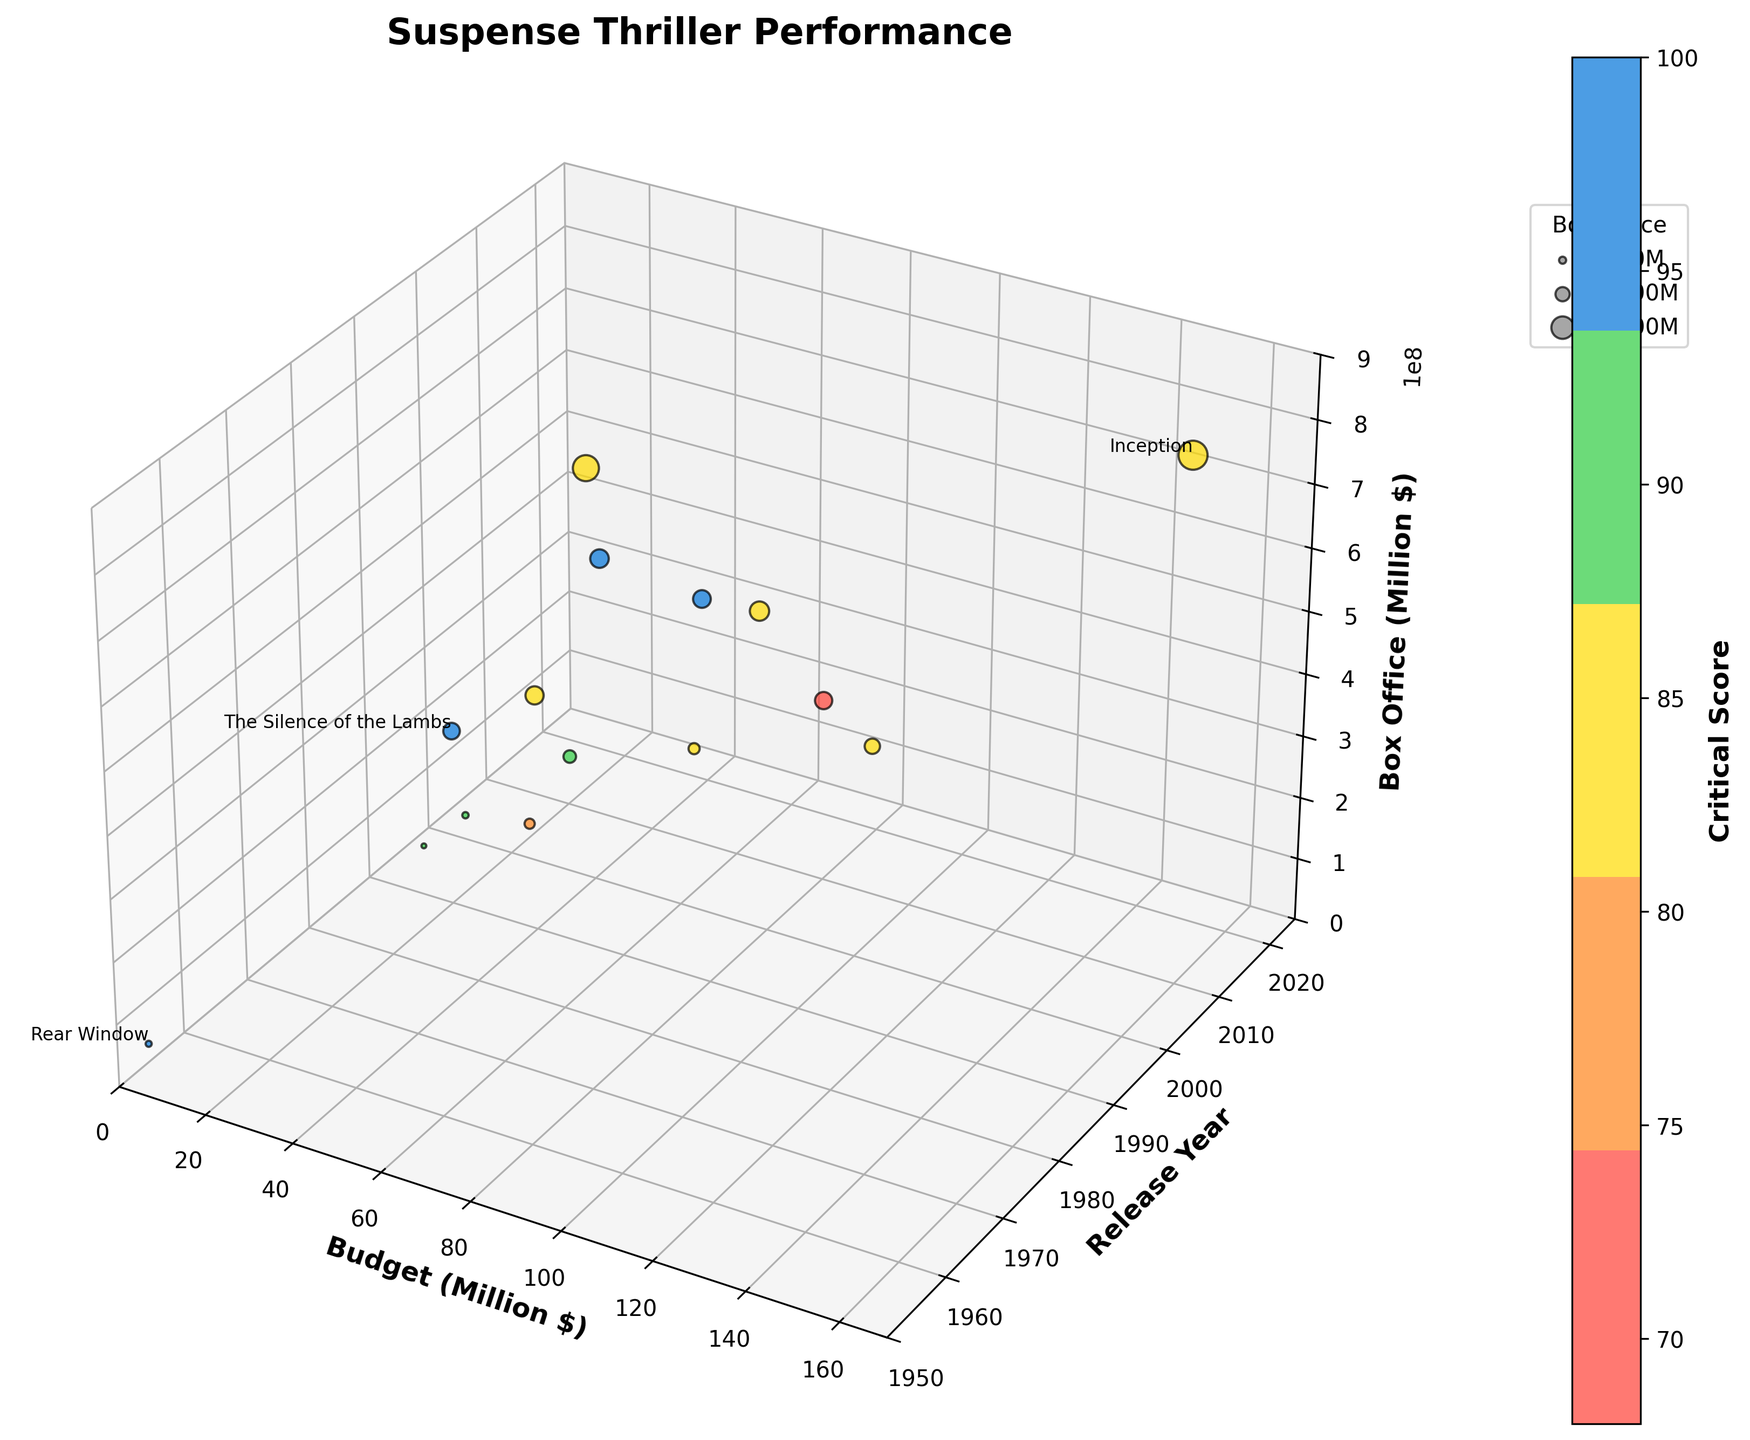How many movies are depicted in the figure? The figure represents a scatter plot with distinct points for each movie. We can count the number of points to determine the total number of movies.
Answer: 15 Which movie had the highest box office performance, and how much did it earn? By looking at the highest point on the z-axis (Box Office), we can see that "Inception" is labeled at the highest point, with earnings at approximately $836.8 million.
Answer: Inception, $836.8 million Which movie, released before the year 2000, had the highest critical score? We filter movies released before 2000 and check the critical scores. "Rear Window," released in 1954, had a perfect critical score of 100.
Answer: Rear Window Which movie released in the 2010s has the largest bubble size, indicating the highest box office revenue? Between 2010 and 2019, "Inception" is the notable movie with the largest bubble size, indicating its high box office revenue.
Answer: Inception Is there a movie with a relatively small budget but high critical and box office performance? Provide an example. By examining the plot, "A Quiet Place" stands out with a relatively small budget of $17 million while achieving a high critical score of 96 and box office revenue of approximately $340.9 million.
Answer: A Quiet Place How does the relationship between budget and box office performance appear to change over time? Observing the plot shows that more recent movies, especially from the 2010s, often have higher budgets and box office earnings. In contrast, older movies typically have lower budgets and box office earnings.
Answer: Higher budgets and box office earnings in recent movies Which movie from the 1990s had a similar budget and critical score but different box office performance compared to "Gone Girl"? "Se7en" from the 1990s had a similar budget ($33 million) and a critical score (81) to "Gone Girl" (Budget $60 million, Critical Score 87), but a different box office performance.
Answer: Se7en Identify two movies from different decades with similar critical scores (within 5 points) but significantly different box office performances. "The Silence of the Lambs" (1991, Critical Score 96, Box Office ~$272.7 million) and "A Quiet Place" (2018, Critical Score 96, Box Office ~$340.9 million) have similar critical scores but different box office performances.
Answer: The Silence of the Lambs and A Quiet Place 